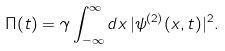Convert formula to latex. <formula><loc_0><loc_0><loc_500><loc_500>\Pi ( t ) = \gamma \int _ { - \infty } ^ { \infty } d x \, | \psi ^ { ( 2 ) } ( x , t ) | ^ { 2 } .</formula> 